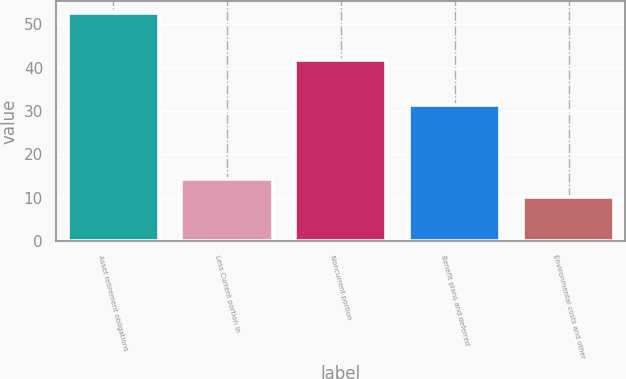Convert chart to OTSL. <chart><loc_0><loc_0><loc_500><loc_500><bar_chart><fcel>Asset retirement obligations<fcel>Less Current portion in<fcel>Noncurrent portion<fcel>Benefit plans and deferred<fcel>Environmental costs and other<nl><fcel>52.7<fcel>14.36<fcel>41.7<fcel>31.4<fcel>10.1<nl></chart> 